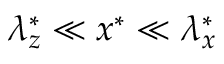Convert formula to latex. <formula><loc_0><loc_0><loc_500><loc_500>\lambda _ { z } ^ { * } \ll x ^ { * } \ll \lambda _ { x } ^ { * }</formula> 